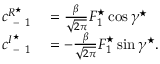Convert formula to latex. <formula><loc_0><loc_0><loc_500><loc_500>\begin{array} { r l } { c _ { - 1 } ^ { R ^ { ^ { * } } } } & = \frac { \beta } { \sqrt { 2 \pi } } F _ { 1 } ^ { ^ { * } } \cos \gamma ^ { ^ { * } } } \\ { c _ { - 1 } ^ { I ^ { ^ { * } } } } & = - \frac { \beta } { \sqrt { 2 \pi } } F _ { 1 } ^ { ^ { * } } \sin \gamma ^ { ^ { * } } . } \end{array}</formula> 